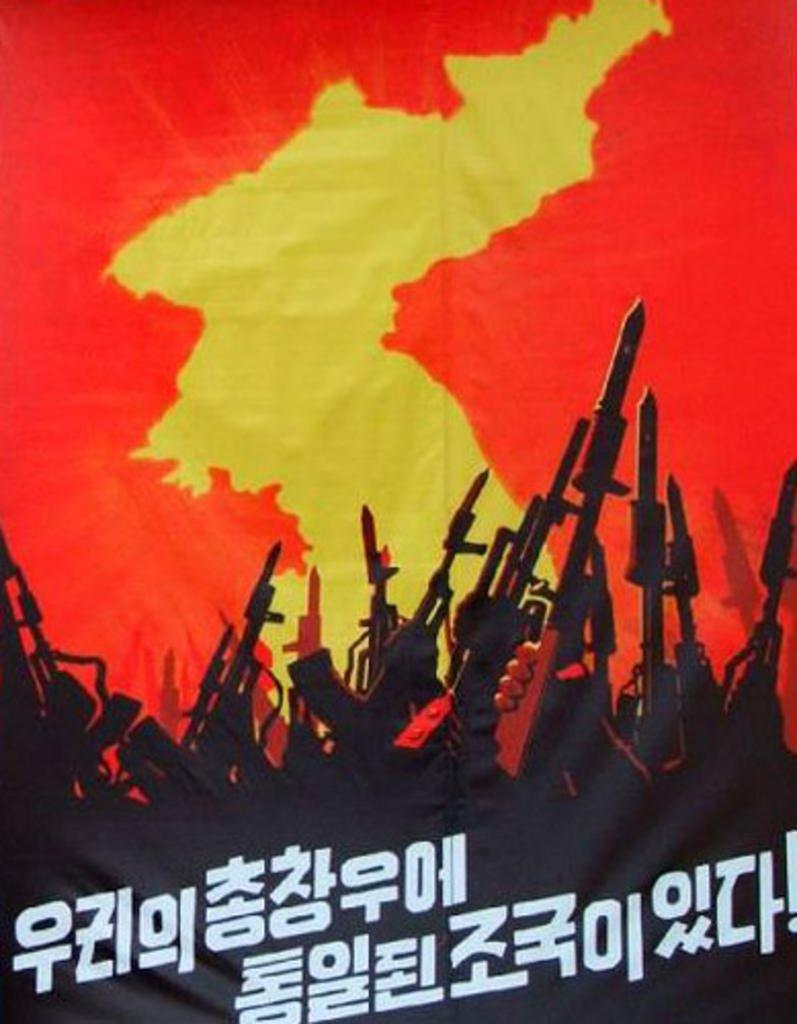What is featured in the image? There is a poster in the image. What can be found on the poster? The poster contains text and a picture of rifles. What type of railway is visible in the image? There is no railway present in the image; it features a poster with text and a picture of rifles. What reward can be seen being given to the person who sneezes in the image? There is no person sneezing or receiving a reward in the image. 